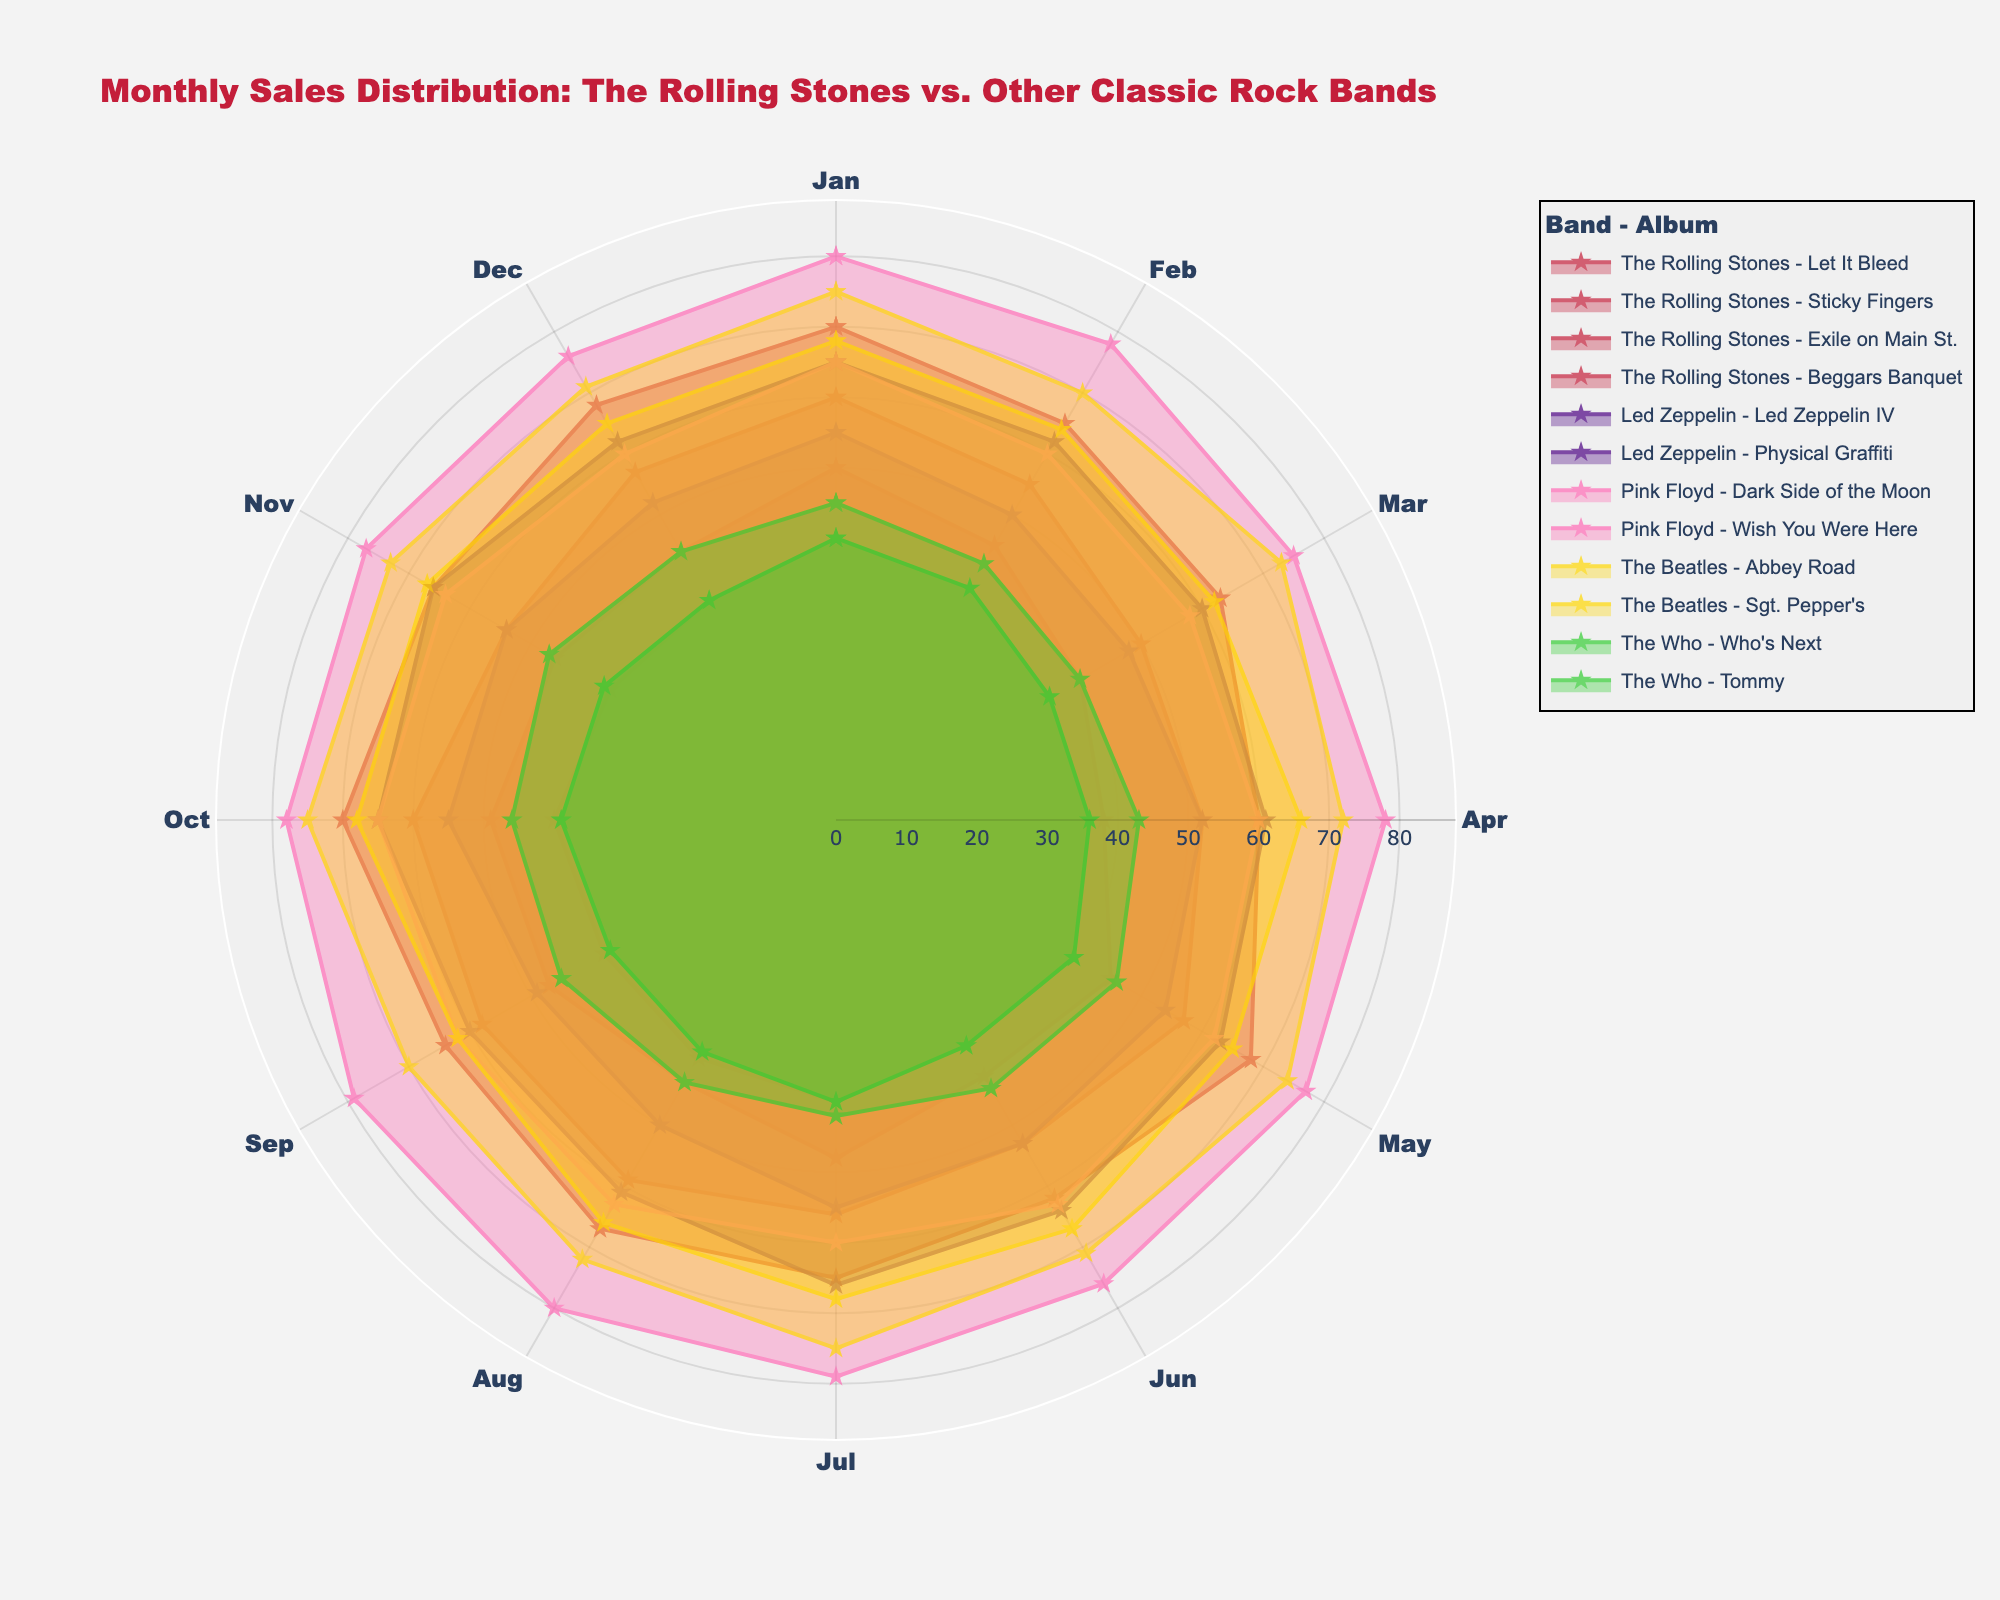What is the title of the radar chart? The title of the radar chart is displayed at the top of the figure, above the polar area. It is written in a larger font size compared to other text elements.
Answer: Monthly Sales Distribution: The Rolling Stones vs. Other Classic Rock Bands Which band's album has the highest sales overall in December? By comparing all the values in December, we see that Pink Floyd's "Dark Side of the Moon" has the highest sales at 76.
Answer: Pink Floyd How do the January sales for The Rolling Stones' "Exile on Main St." compare to Pink Floyd's "Dark Side of the Moon"? The sales for "Exile on Main St." in January are 70, while "Dark Side of the Moon" has sales of 80. 80 is greater than 70.
Answer: Pink Floyd's "Dark Side of the Moon" has higher sales Which month has the highest sales for The Beatles' "Abbey Road"? By comparing the sales values for each month of "Abbey Road", we see that sales peak in January and July at 75 each.
Answer: January & July How do the sales of "Let It Bleed" by The Rolling Stones change from January to May? For "Let It Bleed", the sales figures from January to May are 50, 45, 40, 38, and 45. Sales decrease from January to April and then increase in May.
Answer: Decrease then increase Which The Rolling Stones album has the most consistent monthly sales pattern? By looking at the sales data, "Sticky Fingers" appears to have the most consistent sales pattern, with relatively small fluctuations over the months (highest at 60, lowest at 50).
Answer: Sticky Fingers Comparing The Who's album "Who's Next" to "Tommy", which album shows higher sales in July? Checking the data for July, "Who's Next" has sales of 42, whereas "Tommy" also has sales of 40.
Answer: Who's Next What are the average monthly sales for Led Zeppelin's "Physical Graffiti"? Summing the monthly sales for "Physical Graffiti": 55+50+48+52+54+53+55+50+49+55+54+52 = 627. The average is then 627/12 = 52.25.
Answer: 52.25 Which band's albums fill the largest area on the radar chart? Pink Floyd's albums "Dark Side of the Moon" and "Wish You Were Here" have generally higher values, covering a larger area of the chart.
Answer: Pink Floyd Which month shows the maximum sales for Led Zeppelin IV? Reviewing sales figures for each month for "Led Zeppelin IV", the maximum sales value occurs in January (65).
Answer: January 